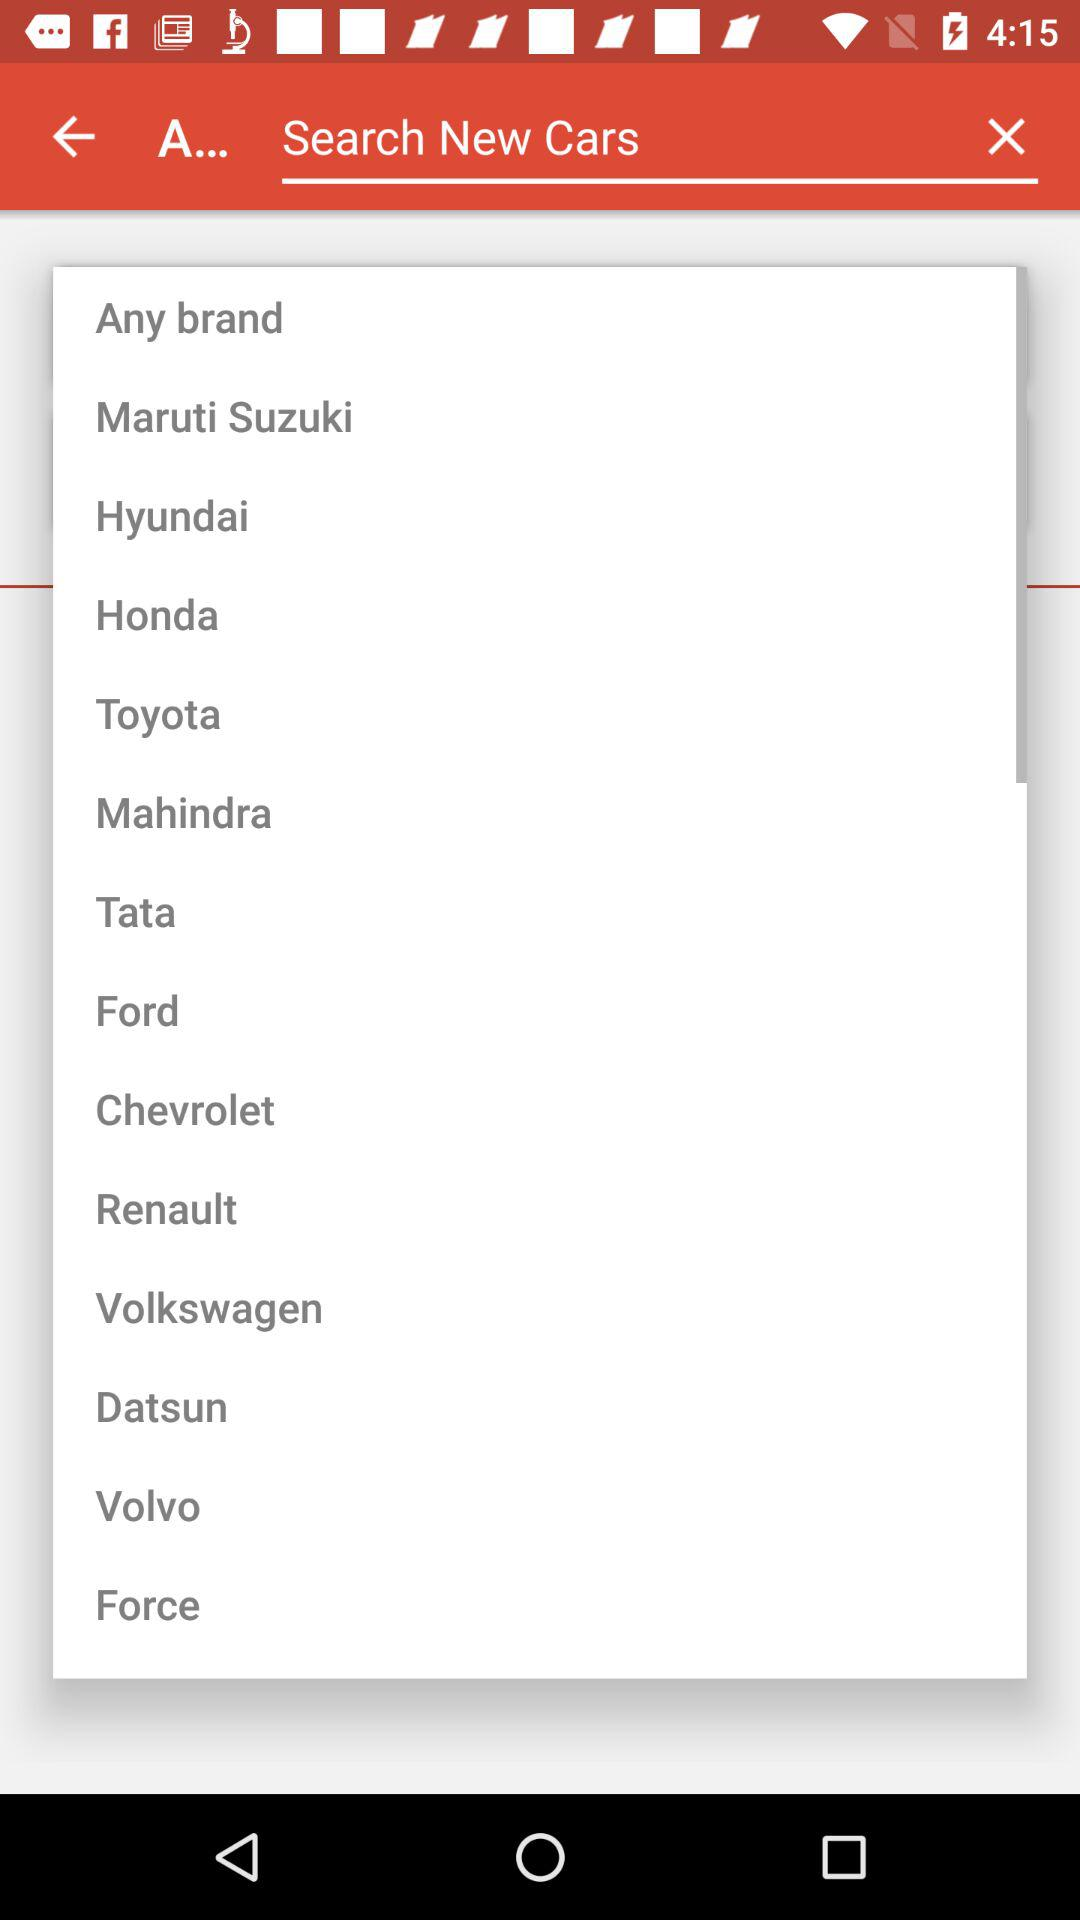What is the text in the input field? The text in the input field is "Search New Cars". 